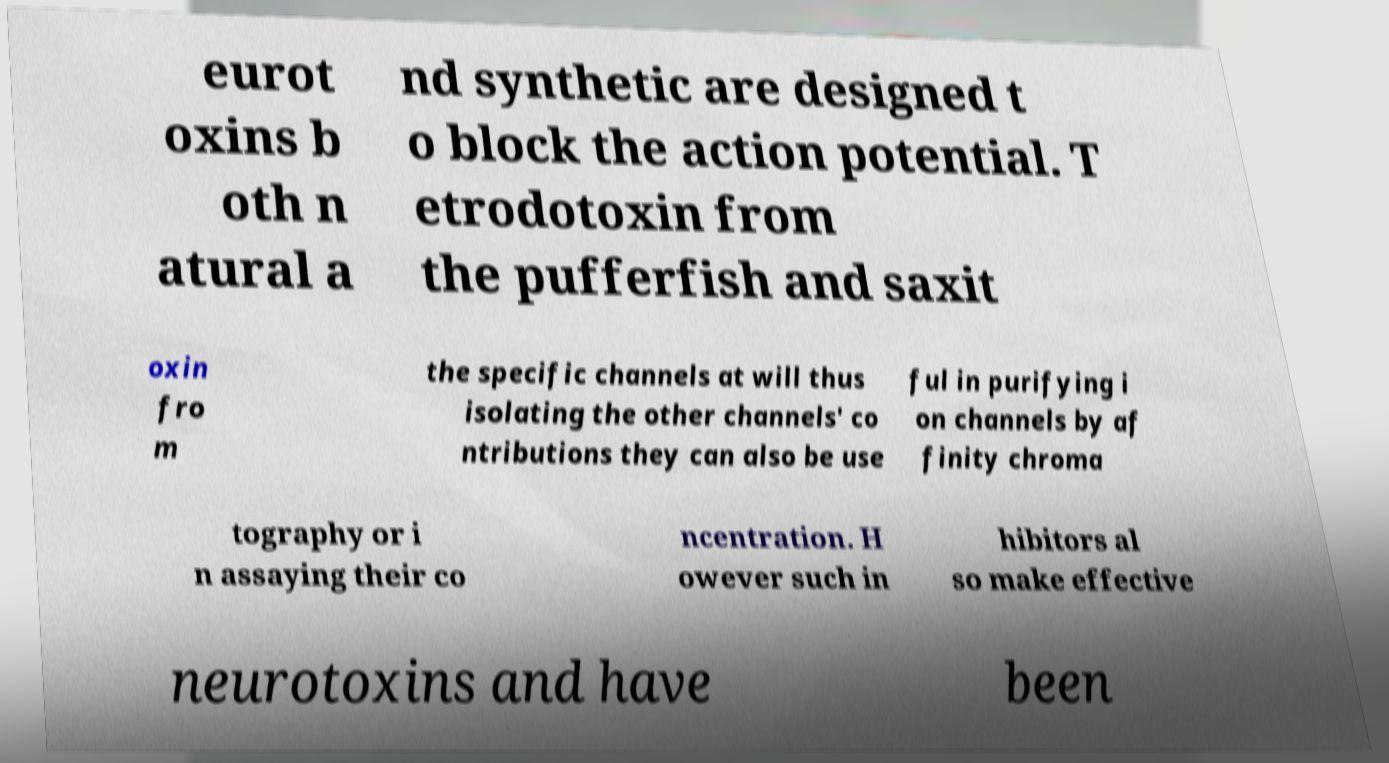There's text embedded in this image that I need extracted. Can you transcribe it verbatim? eurot oxins b oth n atural a nd synthetic are designed t o block the action potential. T etrodotoxin from the pufferfish and saxit oxin fro m the specific channels at will thus isolating the other channels' co ntributions they can also be use ful in purifying i on channels by af finity chroma tography or i n assaying their co ncentration. H owever such in hibitors al so make effective neurotoxins and have been 